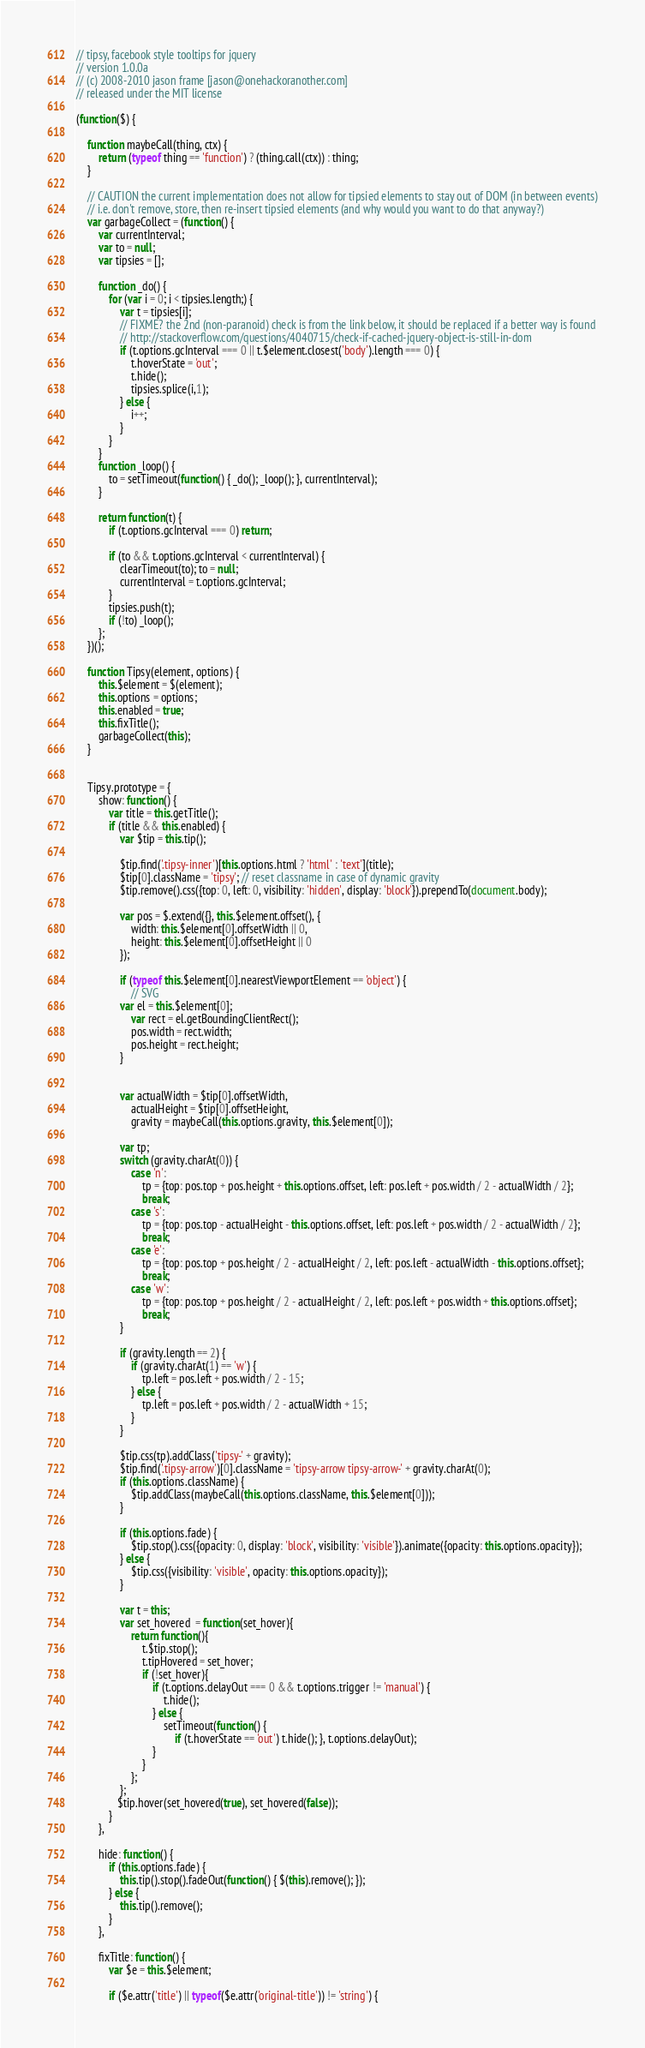<code> <loc_0><loc_0><loc_500><loc_500><_JavaScript_>// tipsy, facebook style tooltips for jquery
// version 1.0.0a
// (c) 2008-2010 jason frame [jason@onehackoranother.com]
// released under the MIT license

(function($) {

    function maybeCall(thing, ctx) {
        return (typeof thing == 'function') ? (thing.call(ctx)) : thing;
    }

    // CAUTION the current implementation does not allow for tipsied elements to stay out of DOM (in between events)
    // i.e. don't remove, store, then re-insert tipsied elements (and why would you want to do that anyway?)
    var garbageCollect = (function() {
        var currentInterval;
        var to = null;
        var tipsies = [];

        function _do() {
            for (var i = 0; i < tipsies.length;) {
                var t = tipsies[i];
                // FIXME? the 2nd (non-paranoid) check is from the link below, it should be replaced if a better way is found
                // http://stackoverflow.com/questions/4040715/check-if-cached-jquery-object-is-still-in-dom
                if (t.options.gcInterval === 0 || t.$element.closest('body').length === 0) {
                    t.hoverState = 'out';
                    t.hide();
                    tipsies.splice(i,1);
                } else {
                    i++;
                }
            }
        }
        function _loop() {
            to = setTimeout(function() { _do(); _loop(); }, currentInterval);
        }

        return function(t) {
            if (t.options.gcInterval === 0) return;

            if (to && t.options.gcInterval < currentInterval) {
                clearTimeout(to); to = null;
                currentInterval = t.options.gcInterval;
            }
            tipsies.push(t);
            if (!to) _loop();
        };
    })();

    function Tipsy(element, options) {
        this.$element = $(element);
        this.options = options;
        this.enabled = true;
        this.fixTitle();
        garbageCollect(this);
    }


    Tipsy.prototype = {
        show: function() {
            var title = this.getTitle();
            if (title && this.enabled) {
                var $tip = this.tip();

                $tip.find('.tipsy-inner')[this.options.html ? 'html' : 'text'](title);
                $tip[0].className = 'tipsy'; // reset classname in case of dynamic gravity
                $tip.remove().css({top: 0, left: 0, visibility: 'hidden', display: 'block'}).prependTo(document.body);

                var pos = $.extend({}, this.$element.offset(), {
                    width: this.$element[0].offsetWidth || 0,
                    height: this.$element[0].offsetHeight || 0
                });

                if (typeof this.$element[0].nearestViewportElement == 'object') {
                    // SVG
  				var el = this.$element[0];
                    var rect = el.getBoundingClientRect();
					pos.width = rect.width;
					pos.height = rect.height;
                }


                var actualWidth = $tip[0].offsetWidth,
                    actualHeight = $tip[0].offsetHeight,
                    gravity = maybeCall(this.options.gravity, this.$element[0]);

                var tp;
                switch (gravity.charAt(0)) {
                    case 'n':
                        tp = {top: pos.top + pos.height + this.options.offset, left: pos.left + pos.width / 2 - actualWidth / 2};
                        break;
                    case 's':
                        tp = {top: pos.top - actualHeight - this.options.offset, left: pos.left + pos.width / 2 - actualWidth / 2};
                        break;
                    case 'e':
                        tp = {top: pos.top + pos.height / 2 - actualHeight / 2, left: pos.left - actualWidth - this.options.offset};
                        break;
                    case 'w':
                        tp = {top: pos.top + pos.height / 2 - actualHeight / 2, left: pos.left + pos.width + this.options.offset};
                        break;
                }

                if (gravity.length == 2) {
                    if (gravity.charAt(1) == 'w') {
                        tp.left = pos.left + pos.width / 2 - 15;
                    } else {
                        tp.left = pos.left + pos.width / 2 - actualWidth + 15;
                    }
                }

                $tip.css(tp).addClass('tipsy-' + gravity);
                $tip.find('.tipsy-arrow')[0].className = 'tipsy-arrow tipsy-arrow-' + gravity.charAt(0);
                if (this.options.className) {
                    $tip.addClass(maybeCall(this.options.className, this.$element[0]));
                }

                if (this.options.fade) {
                    $tip.stop().css({opacity: 0, display: 'block', visibility: 'visible'}).animate({opacity: this.options.opacity});
                } else {
                    $tip.css({visibility: 'visible', opacity: this.options.opacity});
                }

                var t = this;
                var set_hovered  = function(set_hover){
                    return function(){
                        t.$tip.stop();
                        t.tipHovered = set_hover;
                        if (!set_hover){
                            if (t.options.delayOut === 0 && t.options.trigger != 'manual') {
                                t.hide();
                            } else {
                                setTimeout(function() {
                                    if (t.hoverState == 'out') t.hide(); }, t.options.delayOut);
                            }
                        }
                    };
                };
               $tip.hover(set_hovered(true), set_hovered(false));
            }
        },

        hide: function() {
            if (this.options.fade) {
                this.tip().stop().fadeOut(function() { $(this).remove(); });
            } else {
                this.tip().remove();
            }
        },

        fixTitle: function() {
            var $e = this.$element;

            if ($e.attr('title') || typeof($e.attr('original-title')) != 'string') {</code> 